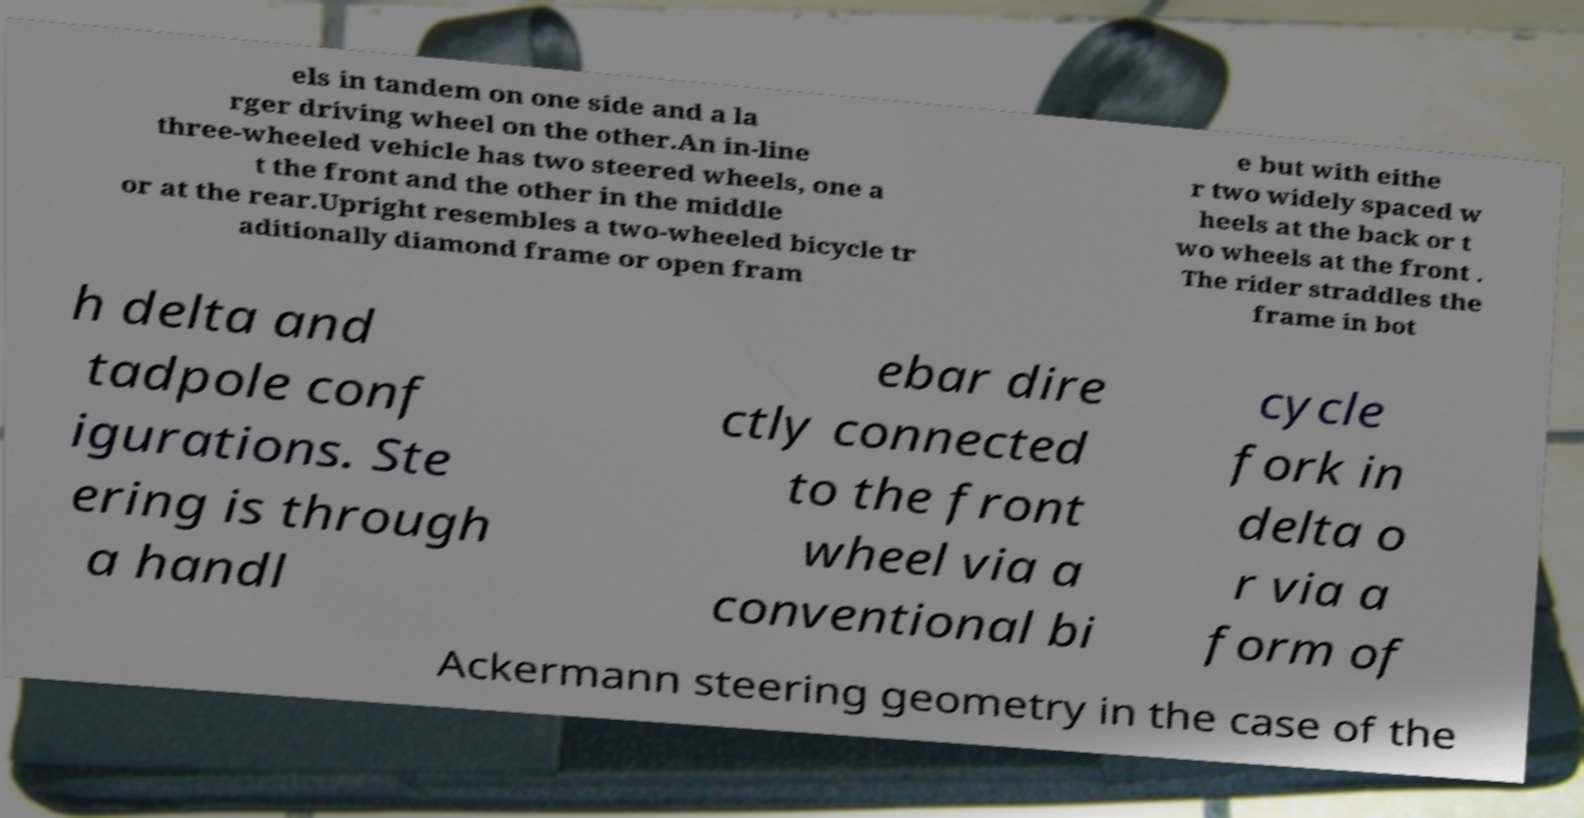Could you extract and type out the text from this image? els in tandem on one side and a la rger driving wheel on the other.An in-line three-wheeled vehicle has two steered wheels, one a t the front and the other in the middle or at the rear.Upright resembles a two-wheeled bicycle tr aditionally diamond frame or open fram e but with eithe r two widely spaced w heels at the back or t wo wheels at the front . The rider straddles the frame in bot h delta and tadpole conf igurations. Ste ering is through a handl ebar dire ctly connected to the front wheel via a conventional bi cycle fork in delta o r via a form of Ackermann steering geometry in the case of the 